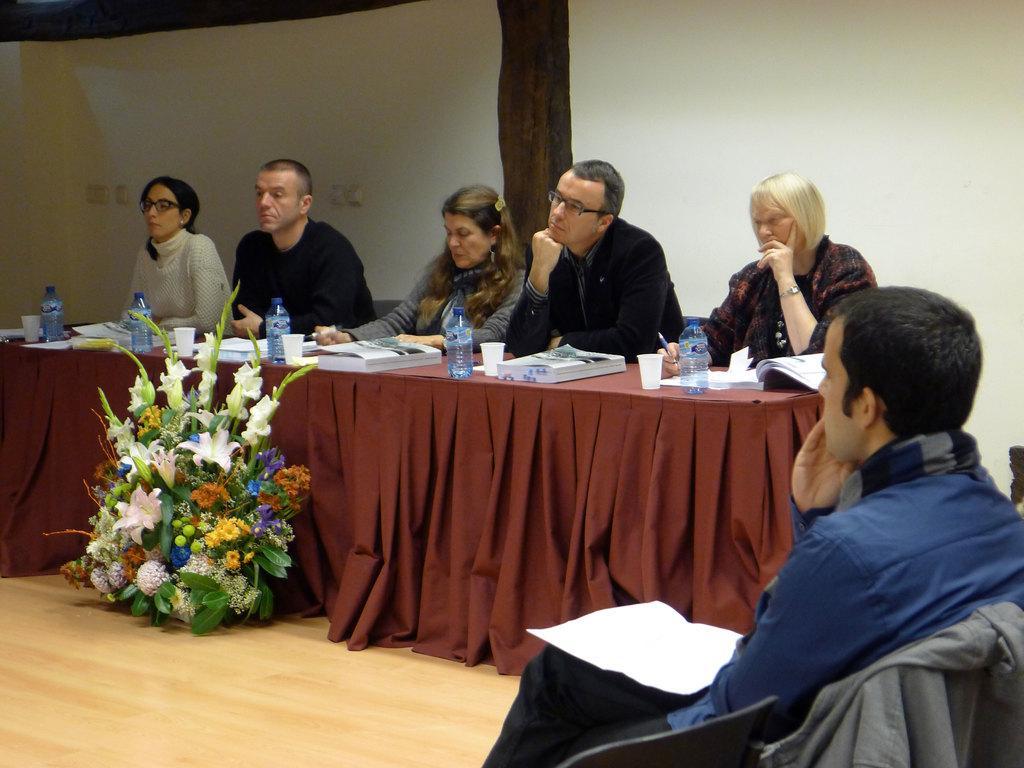In one or two sentences, can you explain what this image depicts? This picture is taken in a room. There are five people sitting besides a table. The table is covered with a red cloth, on the table there are glasses, bottles and books. In front of a table there is a bouquet. Towards the right corner, there is a man wearing a blue shirt, black jeans and there is a paper on him. 